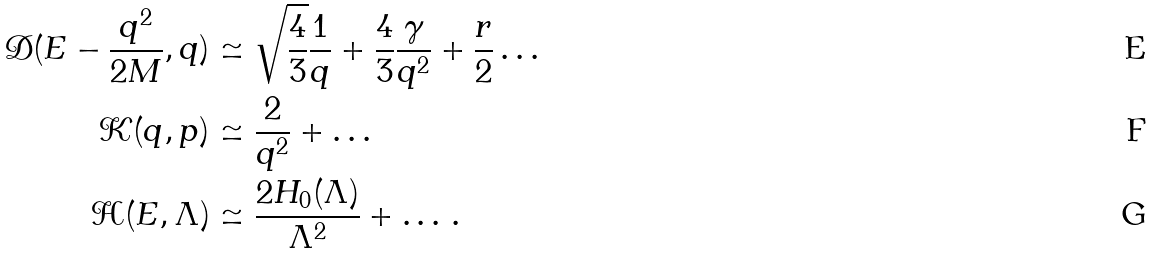Convert formula to latex. <formula><loc_0><loc_0><loc_500><loc_500>\mathcal { D } ( E - \frac { q ^ { 2 } } { 2 M } , q ) & \simeq \sqrt { \frac { 4 } { 3 } } \frac { 1 } { q } + \frac { 4 } { 3 } \frac { \gamma } { q ^ { 2 } } + \frac { r } { 2 } \dots \ \\ { \mathcal { K } } ( q , p ) & \simeq \frac { 2 } { q ^ { 2 } } + \dots \\ { \mathcal { H } } ( E , \Lambda ) & \simeq \frac { 2 H _ { 0 } ( \Lambda ) } { \Lambda ^ { 2 } } + \dots \, .</formula> 